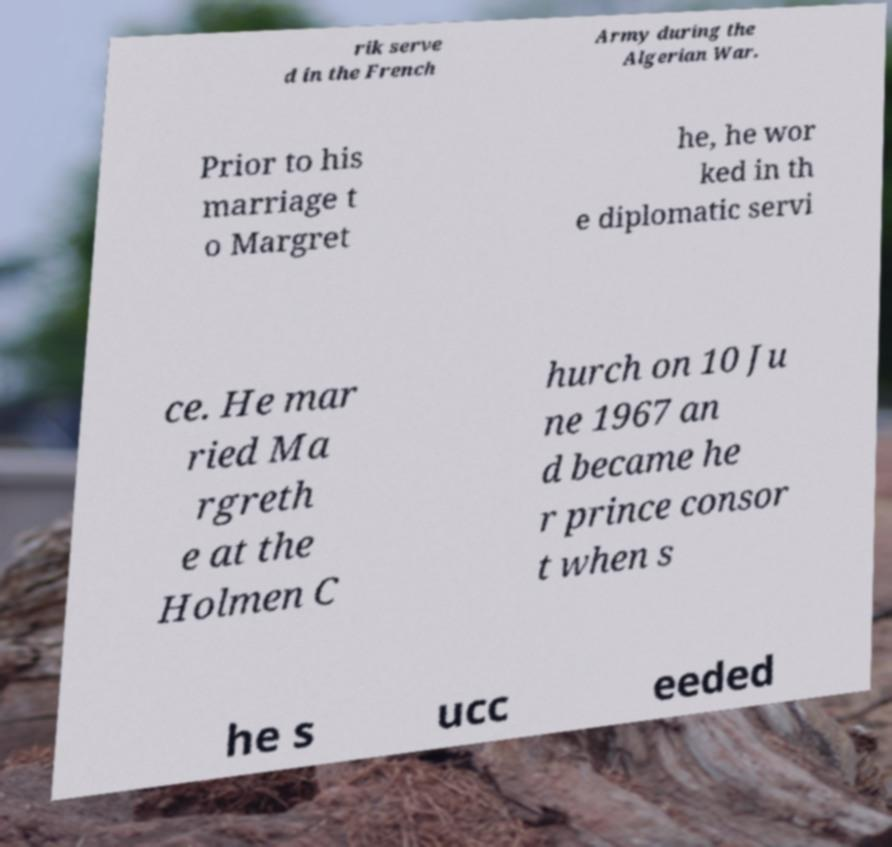Please identify and transcribe the text found in this image. rik serve d in the French Army during the Algerian War. Prior to his marriage t o Margret he, he wor ked in th e diplomatic servi ce. He mar ried Ma rgreth e at the Holmen C hurch on 10 Ju ne 1967 an d became he r prince consor t when s he s ucc eeded 